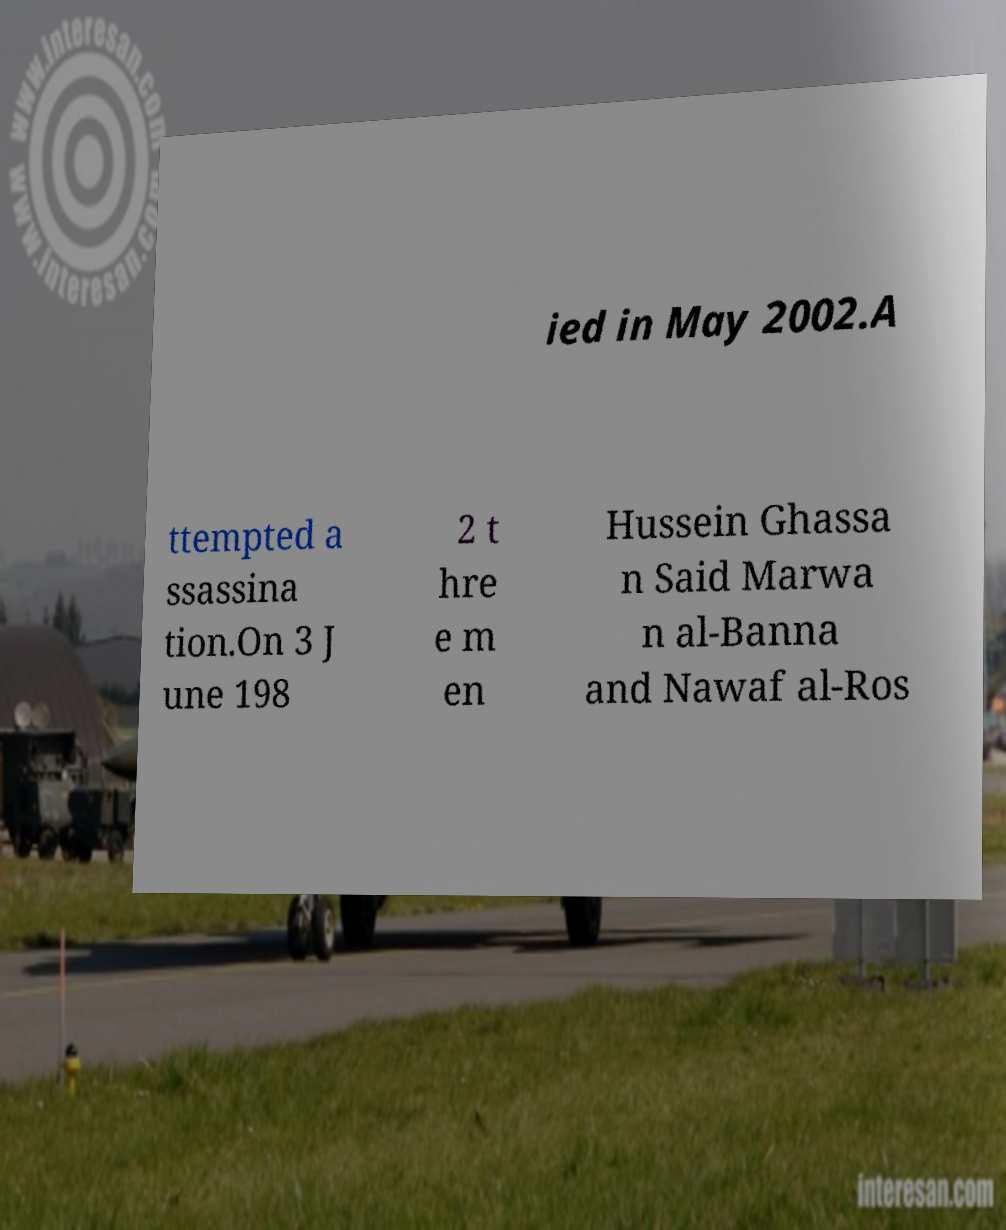What messages or text are displayed in this image? I need them in a readable, typed format. ied in May 2002.A ttempted a ssassina tion.On 3 J une 198 2 t hre e m en Hussein Ghassa n Said Marwa n al-Banna and Nawaf al-Ros 